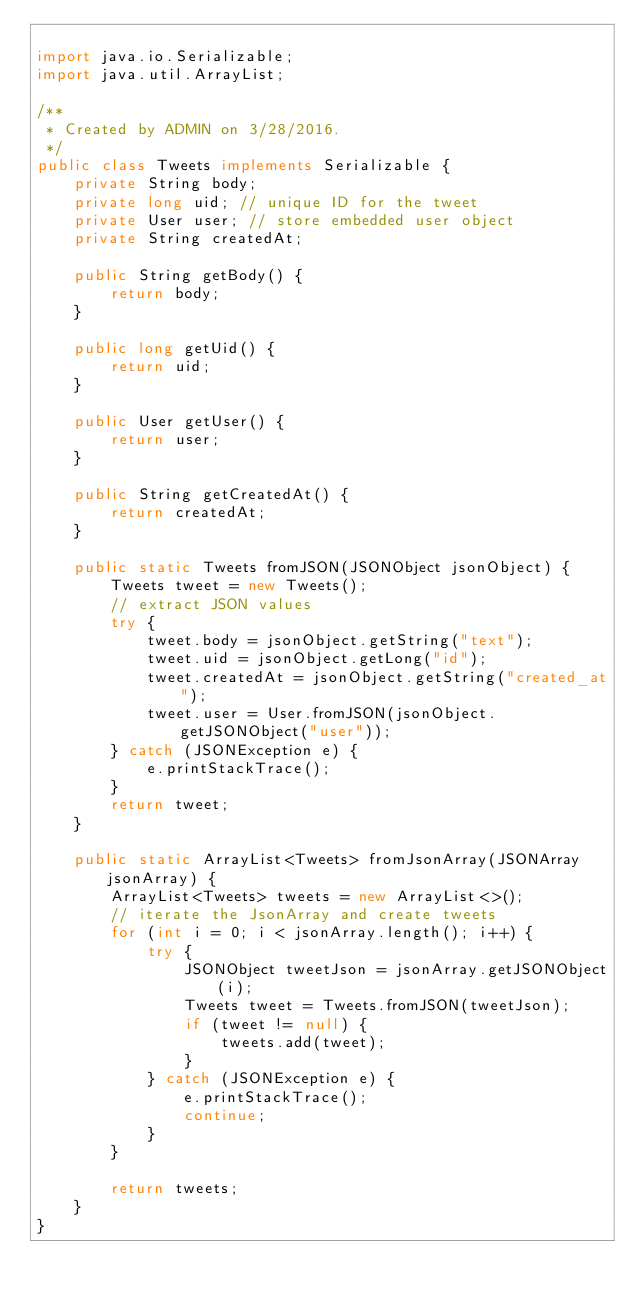<code> <loc_0><loc_0><loc_500><loc_500><_Java_>
import java.io.Serializable;
import java.util.ArrayList;

/**
 * Created by ADMIN on 3/28/2016.
 */
public class Tweets implements Serializable {
    private String body;
    private long uid; // unique ID for the tweet
    private User user; // store embedded user object
    private String createdAt;

    public String getBody() {
        return body;
    }

    public long getUid() {
        return uid;
    }

    public User getUser() {
        return user;
    }

    public String getCreatedAt() {
        return createdAt;
    }

    public static Tweets fromJSON(JSONObject jsonObject) {
        Tweets tweet = new Tweets();
        // extract JSON values
        try {
            tweet.body = jsonObject.getString("text");
            tweet.uid = jsonObject.getLong("id");
            tweet.createdAt = jsonObject.getString("created_at");
            tweet.user = User.fromJSON(jsonObject.getJSONObject("user"));
        } catch (JSONException e) {
            e.printStackTrace();
        }
        return tweet;
    }

    public static ArrayList<Tweets> fromJsonArray(JSONArray jsonArray) {
        ArrayList<Tweets> tweets = new ArrayList<>();
        // iterate the JsonArray and create tweets
        for (int i = 0; i < jsonArray.length(); i++) {
            try {
                JSONObject tweetJson = jsonArray.getJSONObject(i);
                Tweets tweet = Tweets.fromJSON(tweetJson);
                if (tweet != null) {
                    tweets.add(tweet);
                }
            } catch (JSONException e) {
                e.printStackTrace();
                continue;
            }
        }

        return tweets;
    }
}
</code> 